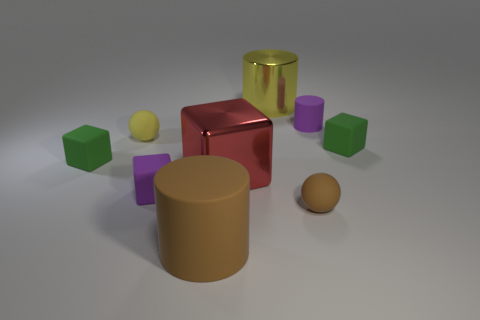How would you describe the arrangement of the objects? The objects are arranged seemingly at random on a flat surface. There's a large yellow cylinder, a red cube, and a tan cylinder at the center, surrounded by smaller objects, including cubes and a sphere.  Can you identify the colors of the cubes other than the red one? Certainly! Aside from the red cube, we have two green cubes, two purple cubes, and a smaller yellow cube. 